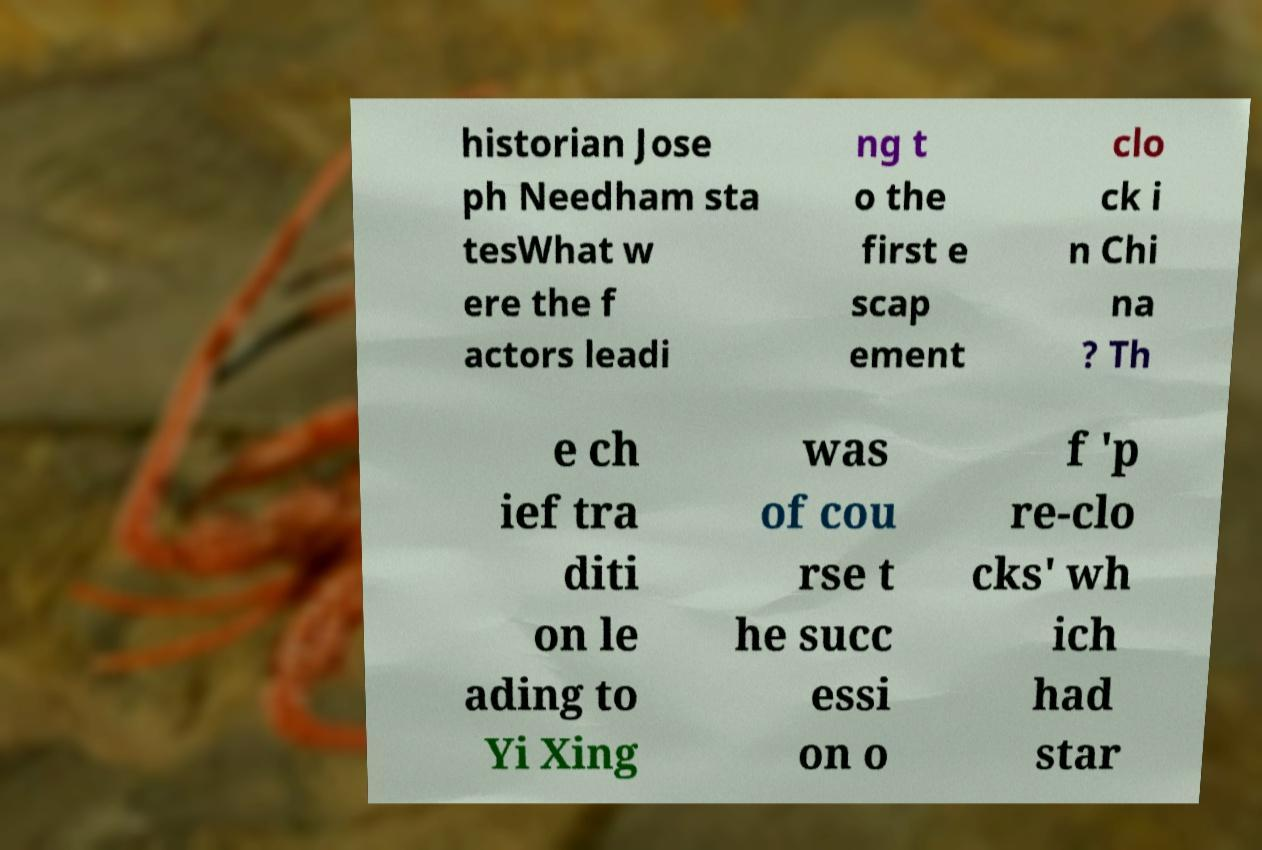I need the written content from this picture converted into text. Can you do that? historian Jose ph Needham sta tesWhat w ere the f actors leadi ng t o the first e scap ement clo ck i n Chi na ? Th e ch ief tra diti on le ading to Yi Xing was of cou rse t he succ essi on o f 'p re-clo cks' wh ich had star 